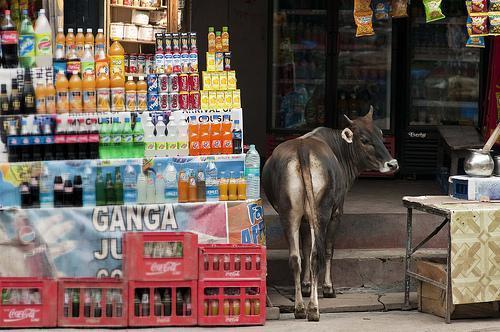How many red crates?
Give a very brief answer. 6. 